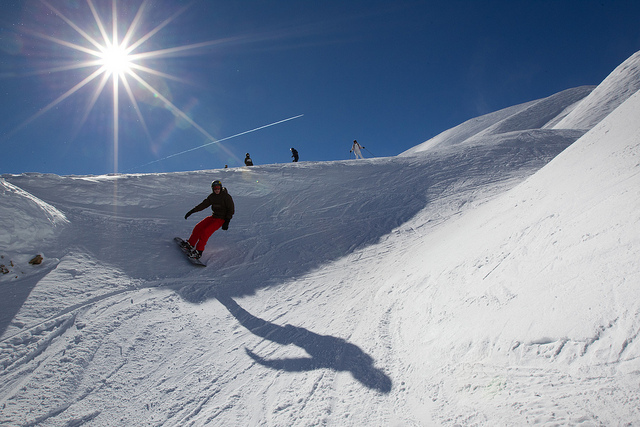Can you describe the environment where the snowboarding is taking place? The snowboarding is happening on a snow-clad mountain under a clear blue sky. The bright sun is shining, creating vivid shadows on the textured snow and providing excellent visibility for winter sports enthusiasts. 